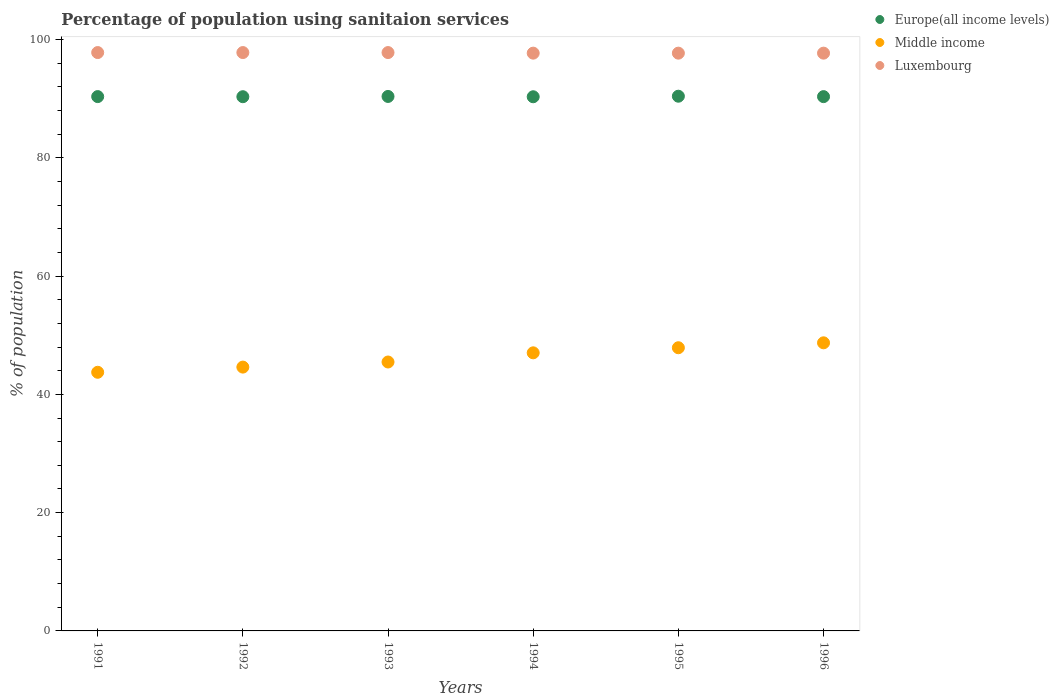What is the percentage of population using sanitaion services in Middle income in 1993?
Ensure brevity in your answer.  45.47. Across all years, what is the maximum percentage of population using sanitaion services in Luxembourg?
Your response must be concise. 97.8. Across all years, what is the minimum percentage of population using sanitaion services in Luxembourg?
Keep it short and to the point. 97.7. In which year was the percentage of population using sanitaion services in Europe(all income levels) maximum?
Your response must be concise. 1995. In which year was the percentage of population using sanitaion services in Middle income minimum?
Make the answer very short. 1991. What is the total percentage of population using sanitaion services in Europe(all income levels) in the graph?
Give a very brief answer. 542.16. What is the difference between the percentage of population using sanitaion services in Luxembourg in 1993 and the percentage of population using sanitaion services in Middle income in 1994?
Offer a very short reply. 50.77. What is the average percentage of population using sanitaion services in Middle income per year?
Your answer should be very brief. 46.24. In the year 1993, what is the difference between the percentage of population using sanitaion services in Europe(all income levels) and percentage of population using sanitaion services in Luxembourg?
Give a very brief answer. -7.42. What is the ratio of the percentage of population using sanitaion services in Luxembourg in 1992 to that in 1993?
Your response must be concise. 1. Is the percentage of population using sanitaion services in Luxembourg in 1993 less than that in 1995?
Ensure brevity in your answer.  No. What is the difference between the highest and the second highest percentage of population using sanitaion services in Europe(all income levels)?
Offer a very short reply. 0.04. What is the difference between the highest and the lowest percentage of population using sanitaion services in Europe(all income levels)?
Give a very brief answer. 0.09. In how many years, is the percentage of population using sanitaion services in Luxembourg greater than the average percentage of population using sanitaion services in Luxembourg taken over all years?
Provide a succinct answer. 3. Is the sum of the percentage of population using sanitaion services in Middle income in 1991 and 1993 greater than the maximum percentage of population using sanitaion services in Luxembourg across all years?
Your answer should be very brief. No. Does the percentage of population using sanitaion services in Luxembourg monotonically increase over the years?
Keep it short and to the point. No. Is the percentage of population using sanitaion services in Europe(all income levels) strictly greater than the percentage of population using sanitaion services in Luxembourg over the years?
Give a very brief answer. No. Are the values on the major ticks of Y-axis written in scientific E-notation?
Offer a terse response. No. Does the graph contain any zero values?
Offer a very short reply. No. What is the title of the graph?
Offer a very short reply. Percentage of population using sanitaion services. What is the label or title of the Y-axis?
Your answer should be compact. % of population. What is the % of population of Europe(all income levels) in 1991?
Provide a succinct answer. 90.35. What is the % of population in Middle income in 1991?
Give a very brief answer. 43.74. What is the % of population of Luxembourg in 1991?
Provide a succinct answer. 97.8. What is the % of population of Europe(all income levels) in 1992?
Your answer should be compact. 90.34. What is the % of population of Middle income in 1992?
Your answer should be compact. 44.61. What is the % of population in Luxembourg in 1992?
Your response must be concise. 97.8. What is the % of population in Europe(all income levels) in 1993?
Ensure brevity in your answer.  90.38. What is the % of population of Middle income in 1993?
Your answer should be very brief. 45.47. What is the % of population of Luxembourg in 1993?
Ensure brevity in your answer.  97.8. What is the % of population of Europe(all income levels) in 1994?
Your answer should be compact. 90.33. What is the % of population of Middle income in 1994?
Offer a very short reply. 47.03. What is the % of population in Luxembourg in 1994?
Make the answer very short. 97.7. What is the % of population of Europe(all income levels) in 1995?
Offer a very short reply. 90.42. What is the % of population in Middle income in 1995?
Provide a short and direct response. 47.89. What is the % of population of Luxembourg in 1995?
Offer a terse response. 97.7. What is the % of population of Europe(all income levels) in 1996?
Offer a very short reply. 90.35. What is the % of population of Middle income in 1996?
Give a very brief answer. 48.72. What is the % of population of Luxembourg in 1996?
Offer a very short reply. 97.7. Across all years, what is the maximum % of population of Europe(all income levels)?
Keep it short and to the point. 90.42. Across all years, what is the maximum % of population of Middle income?
Ensure brevity in your answer.  48.72. Across all years, what is the maximum % of population of Luxembourg?
Provide a short and direct response. 97.8. Across all years, what is the minimum % of population in Europe(all income levels)?
Your response must be concise. 90.33. Across all years, what is the minimum % of population in Middle income?
Ensure brevity in your answer.  43.74. Across all years, what is the minimum % of population in Luxembourg?
Make the answer very short. 97.7. What is the total % of population in Europe(all income levels) in the graph?
Provide a succinct answer. 542.16. What is the total % of population in Middle income in the graph?
Ensure brevity in your answer.  277.45. What is the total % of population of Luxembourg in the graph?
Offer a terse response. 586.5. What is the difference between the % of population of Europe(all income levels) in 1991 and that in 1992?
Offer a terse response. 0.02. What is the difference between the % of population of Middle income in 1991 and that in 1992?
Provide a succinct answer. -0.88. What is the difference between the % of population of Europe(all income levels) in 1991 and that in 1993?
Your answer should be compact. -0.02. What is the difference between the % of population of Middle income in 1991 and that in 1993?
Provide a short and direct response. -1.74. What is the difference between the % of population in Europe(all income levels) in 1991 and that in 1994?
Provide a short and direct response. 0.03. What is the difference between the % of population of Middle income in 1991 and that in 1994?
Offer a very short reply. -3.29. What is the difference between the % of population in Europe(all income levels) in 1991 and that in 1995?
Your response must be concise. -0.06. What is the difference between the % of population of Middle income in 1991 and that in 1995?
Provide a succinct answer. -4.15. What is the difference between the % of population of Luxembourg in 1991 and that in 1995?
Keep it short and to the point. 0.1. What is the difference between the % of population in Europe(all income levels) in 1991 and that in 1996?
Ensure brevity in your answer.  0.01. What is the difference between the % of population in Middle income in 1991 and that in 1996?
Your answer should be compact. -4.98. What is the difference between the % of population of Luxembourg in 1991 and that in 1996?
Provide a succinct answer. 0.1. What is the difference between the % of population in Europe(all income levels) in 1992 and that in 1993?
Provide a succinct answer. -0.04. What is the difference between the % of population of Middle income in 1992 and that in 1993?
Make the answer very short. -0.86. What is the difference between the % of population of Luxembourg in 1992 and that in 1993?
Ensure brevity in your answer.  0. What is the difference between the % of population of Europe(all income levels) in 1992 and that in 1994?
Ensure brevity in your answer.  0.01. What is the difference between the % of population in Middle income in 1992 and that in 1994?
Keep it short and to the point. -2.41. What is the difference between the % of population in Europe(all income levels) in 1992 and that in 1995?
Your answer should be very brief. -0.08. What is the difference between the % of population of Middle income in 1992 and that in 1995?
Ensure brevity in your answer.  -3.27. What is the difference between the % of population of Europe(all income levels) in 1992 and that in 1996?
Make the answer very short. -0.01. What is the difference between the % of population in Middle income in 1992 and that in 1996?
Your response must be concise. -4.11. What is the difference between the % of population of Luxembourg in 1992 and that in 1996?
Give a very brief answer. 0.1. What is the difference between the % of population in Europe(all income levels) in 1993 and that in 1994?
Provide a short and direct response. 0.05. What is the difference between the % of population of Middle income in 1993 and that in 1994?
Give a very brief answer. -1.55. What is the difference between the % of population in Luxembourg in 1993 and that in 1994?
Your answer should be very brief. 0.1. What is the difference between the % of population in Europe(all income levels) in 1993 and that in 1995?
Provide a succinct answer. -0.04. What is the difference between the % of population in Middle income in 1993 and that in 1995?
Give a very brief answer. -2.41. What is the difference between the % of population in Luxembourg in 1993 and that in 1995?
Ensure brevity in your answer.  0.1. What is the difference between the % of population in Europe(all income levels) in 1993 and that in 1996?
Your answer should be very brief. 0.03. What is the difference between the % of population in Middle income in 1993 and that in 1996?
Offer a very short reply. -3.24. What is the difference between the % of population in Luxembourg in 1993 and that in 1996?
Give a very brief answer. 0.1. What is the difference between the % of population in Europe(all income levels) in 1994 and that in 1995?
Your response must be concise. -0.09. What is the difference between the % of population in Middle income in 1994 and that in 1995?
Provide a short and direct response. -0.86. What is the difference between the % of population in Europe(all income levels) in 1994 and that in 1996?
Make the answer very short. -0.02. What is the difference between the % of population in Middle income in 1994 and that in 1996?
Make the answer very short. -1.69. What is the difference between the % of population of Europe(all income levels) in 1995 and that in 1996?
Your answer should be compact. 0.07. What is the difference between the % of population in Middle income in 1995 and that in 1996?
Offer a very short reply. -0.83. What is the difference between the % of population in Luxembourg in 1995 and that in 1996?
Your response must be concise. 0. What is the difference between the % of population in Europe(all income levels) in 1991 and the % of population in Middle income in 1992?
Ensure brevity in your answer.  45.74. What is the difference between the % of population of Europe(all income levels) in 1991 and the % of population of Luxembourg in 1992?
Provide a short and direct response. -7.45. What is the difference between the % of population in Middle income in 1991 and the % of population in Luxembourg in 1992?
Your answer should be very brief. -54.06. What is the difference between the % of population of Europe(all income levels) in 1991 and the % of population of Middle income in 1993?
Offer a very short reply. 44.88. What is the difference between the % of population in Europe(all income levels) in 1991 and the % of population in Luxembourg in 1993?
Ensure brevity in your answer.  -7.45. What is the difference between the % of population in Middle income in 1991 and the % of population in Luxembourg in 1993?
Ensure brevity in your answer.  -54.06. What is the difference between the % of population of Europe(all income levels) in 1991 and the % of population of Middle income in 1994?
Your answer should be very brief. 43.33. What is the difference between the % of population of Europe(all income levels) in 1991 and the % of population of Luxembourg in 1994?
Your answer should be very brief. -7.35. What is the difference between the % of population in Middle income in 1991 and the % of population in Luxembourg in 1994?
Offer a very short reply. -53.96. What is the difference between the % of population of Europe(all income levels) in 1991 and the % of population of Middle income in 1995?
Make the answer very short. 42.47. What is the difference between the % of population of Europe(all income levels) in 1991 and the % of population of Luxembourg in 1995?
Your answer should be compact. -7.35. What is the difference between the % of population of Middle income in 1991 and the % of population of Luxembourg in 1995?
Ensure brevity in your answer.  -53.96. What is the difference between the % of population of Europe(all income levels) in 1991 and the % of population of Middle income in 1996?
Offer a terse response. 41.64. What is the difference between the % of population in Europe(all income levels) in 1991 and the % of population in Luxembourg in 1996?
Keep it short and to the point. -7.35. What is the difference between the % of population of Middle income in 1991 and the % of population of Luxembourg in 1996?
Your answer should be compact. -53.96. What is the difference between the % of population in Europe(all income levels) in 1992 and the % of population in Middle income in 1993?
Your answer should be very brief. 44.86. What is the difference between the % of population in Europe(all income levels) in 1992 and the % of population in Luxembourg in 1993?
Keep it short and to the point. -7.46. What is the difference between the % of population of Middle income in 1992 and the % of population of Luxembourg in 1993?
Offer a terse response. -53.19. What is the difference between the % of population of Europe(all income levels) in 1992 and the % of population of Middle income in 1994?
Offer a terse response. 43.31. What is the difference between the % of population of Europe(all income levels) in 1992 and the % of population of Luxembourg in 1994?
Ensure brevity in your answer.  -7.36. What is the difference between the % of population in Middle income in 1992 and the % of population in Luxembourg in 1994?
Offer a very short reply. -53.09. What is the difference between the % of population of Europe(all income levels) in 1992 and the % of population of Middle income in 1995?
Keep it short and to the point. 42.45. What is the difference between the % of population of Europe(all income levels) in 1992 and the % of population of Luxembourg in 1995?
Offer a very short reply. -7.36. What is the difference between the % of population in Middle income in 1992 and the % of population in Luxembourg in 1995?
Your response must be concise. -53.09. What is the difference between the % of population of Europe(all income levels) in 1992 and the % of population of Middle income in 1996?
Your answer should be very brief. 41.62. What is the difference between the % of population of Europe(all income levels) in 1992 and the % of population of Luxembourg in 1996?
Provide a short and direct response. -7.36. What is the difference between the % of population of Middle income in 1992 and the % of population of Luxembourg in 1996?
Your answer should be compact. -53.09. What is the difference between the % of population in Europe(all income levels) in 1993 and the % of population in Middle income in 1994?
Provide a short and direct response. 43.35. What is the difference between the % of population in Europe(all income levels) in 1993 and the % of population in Luxembourg in 1994?
Your answer should be very brief. -7.32. What is the difference between the % of population of Middle income in 1993 and the % of population of Luxembourg in 1994?
Offer a terse response. -52.23. What is the difference between the % of population of Europe(all income levels) in 1993 and the % of population of Middle income in 1995?
Offer a very short reply. 42.49. What is the difference between the % of population in Europe(all income levels) in 1993 and the % of population in Luxembourg in 1995?
Your response must be concise. -7.32. What is the difference between the % of population in Middle income in 1993 and the % of population in Luxembourg in 1995?
Your response must be concise. -52.23. What is the difference between the % of population of Europe(all income levels) in 1993 and the % of population of Middle income in 1996?
Your answer should be very brief. 41.66. What is the difference between the % of population in Europe(all income levels) in 1993 and the % of population in Luxembourg in 1996?
Ensure brevity in your answer.  -7.32. What is the difference between the % of population of Middle income in 1993 and the % of population of Luxembourg in 1996?
Your answer should be very brief. -52.23. What is the difference between the % of population in Europe(all income levels) in 1994 and the % of population in Middle income in 1995?
Your answer should be compact. 42.44. What is the difference between the % of population in Europe(all income levels) in 1994 and the % of population in Luxembourg in 1995?
Offer a terse response. -7.37. What is the difference between the % of population of Middle income in 1994 and the % of population of Luxembourg in 1995?
Ensure brevity in your answer.  -50.67. What is the difference between the % of population in Europe(all income levels) in 1994 and the % of population in Middle income in 1996?
Provide a short and direct response. 41.61. What is the difference between the % of population in Europe(all income levels) in 1994 and the % of population in Luxembourg in 1996?
Keep it short and to the point. -7.37. What is the difference between the % of population in Middle income in 1994 and the % of population in Luxembourg in 1996?
Offer a terse response. -50.67. What is the difference between the % of population in Europe(all income levels) in 1995 and the % of population in Middle income in 1996?
Your response must be concise. 41.7. What is the difference between the % of population in Europe(all income levels) in 1995 and the % of population in Luxembourg in 1996?
Your answer should be very brief. -7.28. What is the difference between the % of population of Middle income in 1995 and the % of population of Luxembourg in 1996?
Provide a short and direct response. -49.81. What is the average % of population in Europe(all income levels) per year?
Your answer should be compact. 90.36. What is the average % of population in Middle income per year?
Give a very brief answer. 46.24. What is the average % of population in Luxembourg per year?
Your answer should be very brief. 97.75. In the year 1991, what is the difference between the % of population in Europe(all income levels) and % of population in Middle income?
Provide a succinct answer. 46.62. In the year 1991, what is the difference between the % of population of Europe(all income levels) and % of population of Luxembourg?
Provide a succinct answer. -7.45. In the year 1991, what is the difference between the % of population in Middle income and % of population in Luxembourg?
Offer a terse response. -54.06. In the year 1992, what is the difference between the % of population in Europe(all income levels) and % of population in Middle income?
Give a very brief answer. 45.72. In the year 1992, what is the difference between the % of population of Europe(all income levels) and % of population of Luxembourg?
Give a very brief answer. -7.46. In the year 1992, what is the difference between the % of population in Middle income and % of population in Luxembourg?
Give a very brief answer. -53.19. In the year 1993, what is the difference between the % of population of Europe(all income levels) and % of population of Middle income?
Provide a short and direct response. 44.9. In the year 1993, what is the difference between the % of population of Europe(all income levels) and % of population of Luxembourg?
Offer a very short reply. -7.42. In the year 1993, what is the difference between the % of population of Middle income and % of population of Luxembourg?
Provide a short and direct response. -52.33. In the year 1994, what is the difference between the % of population of Europe(all income levels) and % of population of Middle income?
Offer a very short reply. 43.3. In the year 1994, what is the difference between the % of population of Europe(all income levels) and % of population of Luxembourg?
Provide a short and direct response. -7.37. In the year 1994, what is the difference between the % of population of Middle income and % of population of Luxembourg?
Offer a very short reply. -50.67. In the year 1995, what is the difference between the % of population of Europe(all income levels) and % of population of Middle income?
Offer a very short reply. 42.53. In the year 1995, what is the difference between the % of population of Europe(all income levels) and % of population of Luxembourg?
Keep it short and to the point. -7.28. In the year 1995, what is the difference between the % of population in Middle income and % of population in Luxembourg?
Give a very brief answer. -49.81. In the year 1996, what is the difference between the % of population of Europe(all income levels) and % of population of Middle income?
Your answer should be compact. 41.63. In the year 1996, what is the difference between the % of population in Europe(all income levels) and % of population in Luxembourg?
Provide a succinct answer. -7.35. In the year 1996, what is the difference between the % of population of Middle income and % of population of Luxembourg?
Provide a short and direct response. -48.98. What is the ratio of the % of population in Middle income in 1991 to that in 1992?
Offer a very short reply. 0.98. What is the ratio of the % of population of Luxembourg in 1991 to that in 1992?
Offer a terse response. 1. What is the ratio of the % of population of Middle income in 1991 to that in 1993?
Ensure brevity in your answer.  0.96. What is the ratio of the % of population in Luxembourg in 1991 to that in 1993?
Your response must be concise. 1. What is the ratio of the % of population of Europe(all income levels) in 1991 to that in 1994?
Provide a short and direct response. 1. What is the ratio of the % of population of Luxembourg in 1991 to that in 1994?
Keep it short and to the point. 1. What is the ratio of the % of population of Europe(all income levels) in 1991 to that in 1995?
Your answer should be compact. 1. What is the ratio of the % of population in Middle income in 1991 to that in 1995?
Offer a terse response. 0.91. What is the ratio of the % of population in Middle income in 1991 to that in 1996?
Offer a very short reply. 0.9. What is the ratio of the % of population of Luxembourg in 1991 to that in 1996?
Provide a short and direct response. 1. What is the ratio of the % of population of Middle income in 1992 to that in 1993?
Make the answer very short. 0.98. What is the ratio of the % of population of Luxembourg in 1992 to that in 1993?
Offer a terse response. 1. What is the ratio of the % of population in Middle income in 1992 to that in 1994?
Offer a very short reply. 0.95. What is the ratio of the % of population in Luxembourg in 1992 to that in 1994?
Make the answer very short. 1. What is the ratio of the % of population in Middle income in 1992 to that in 1995?
Ensure brevity in your answer.  0.93. What is the ratio of the % of population in Luxembourg in 1992 to that in 1995?
Make the answer very short. 1. What is the ratio of the % of population in Europe(all income levels) in 1992 to that in 1996?
Give a very brief answer. 1. What is the ratio of the % of population of Middle income in 1992 to that in 1996?
Offer a terse response. 0.92. What is the ratio of the % of population in Middle income in 1993 to that in 1994?
Your answer should be compact. 0.97. What is the ratio of the % of population in Europe(all income levels) in 1993 to that in 1995?
Your response must be concise. 1. What is the ratio of the % of population of Middle income in 1993 to that in 1995?
Your answer should be very brief. 0.95. What is the ratio of the % of population of Europe(all income levels) in 1993 to that in 1996?
Keep it short and to the point. 1. What is the ratio of the % of population in Middle income in 1993 to that in 1996?
Your answer should be very brief. 0.93. What is the ratio of the % of population of Europe(all income levels) in 1994 to that in 1995?
Your answer should be very brief. 1. What is the ratio of the % of population in Middle income in 1994 to that in 1995?
Your answer should be very brief. 0.98. What is the ratio of the % of population of Europe(all income levels) in 1994 to that in 1996?
Keep it short and to the point. 1. What is the ratio of the % of population of Middle income in 1994 to that in 1996?
Your answer should be very brief. 0.97. What is the ratio of the % of population in Middle income in 1995 to that in 1996?
Make the answer very short. 0.98. What is the ratio of the % of population of Luxembourg in 1995 to that in 1996?
Your answer should be compact. 1. What is the difference between the highest and the second highest % of population of Europe(all income levels)?
Your response must be concise. 0.04. What is the difference between the highest and the second highest % of population in Middle income?
Make the answer very short. 0.83. What is the difference between the highest and the second highest % of population in Luxembourg?
Give a very brief answer. 0. What is the difference between the highest and the lowest % of population in Europe(all income levels)?
Ensure brevity in your answer.  0.09. What is the difference between the highest and the lowest % of population of Middle income?
Keep it short and to the point. 4.98. What is the difference between the highest and the lowest % of population of Luxembourg?
Ensure brevity in your answer.  0.1. 